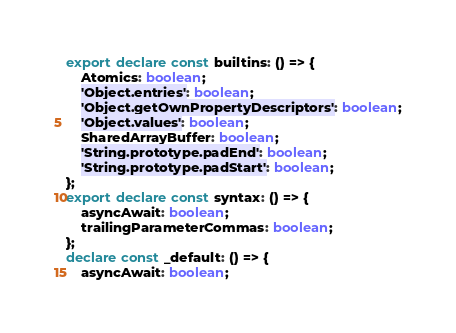Convert code to text. <code><loc_0><loc_0><loc_500><loc_500><_TypeScript_>export declare const builtins: () => {
    Atomics: boolean;
    'Object.entries': boolean;
    'Object.getOwnPropertyDescriptors': boolean;
    'Object.values': boolean;
    SharedArrayBuffer: boolean;
    'String.prototype.padEnd': boolean;
    'String.prototype.padStart': boolean;
};
export declare const syntax: () => {
    asyncAwait: boolean;
    trailingParameterCommas: boolean;
};
declare const _default: () => {
    asyncAwait: boolean;</code> 